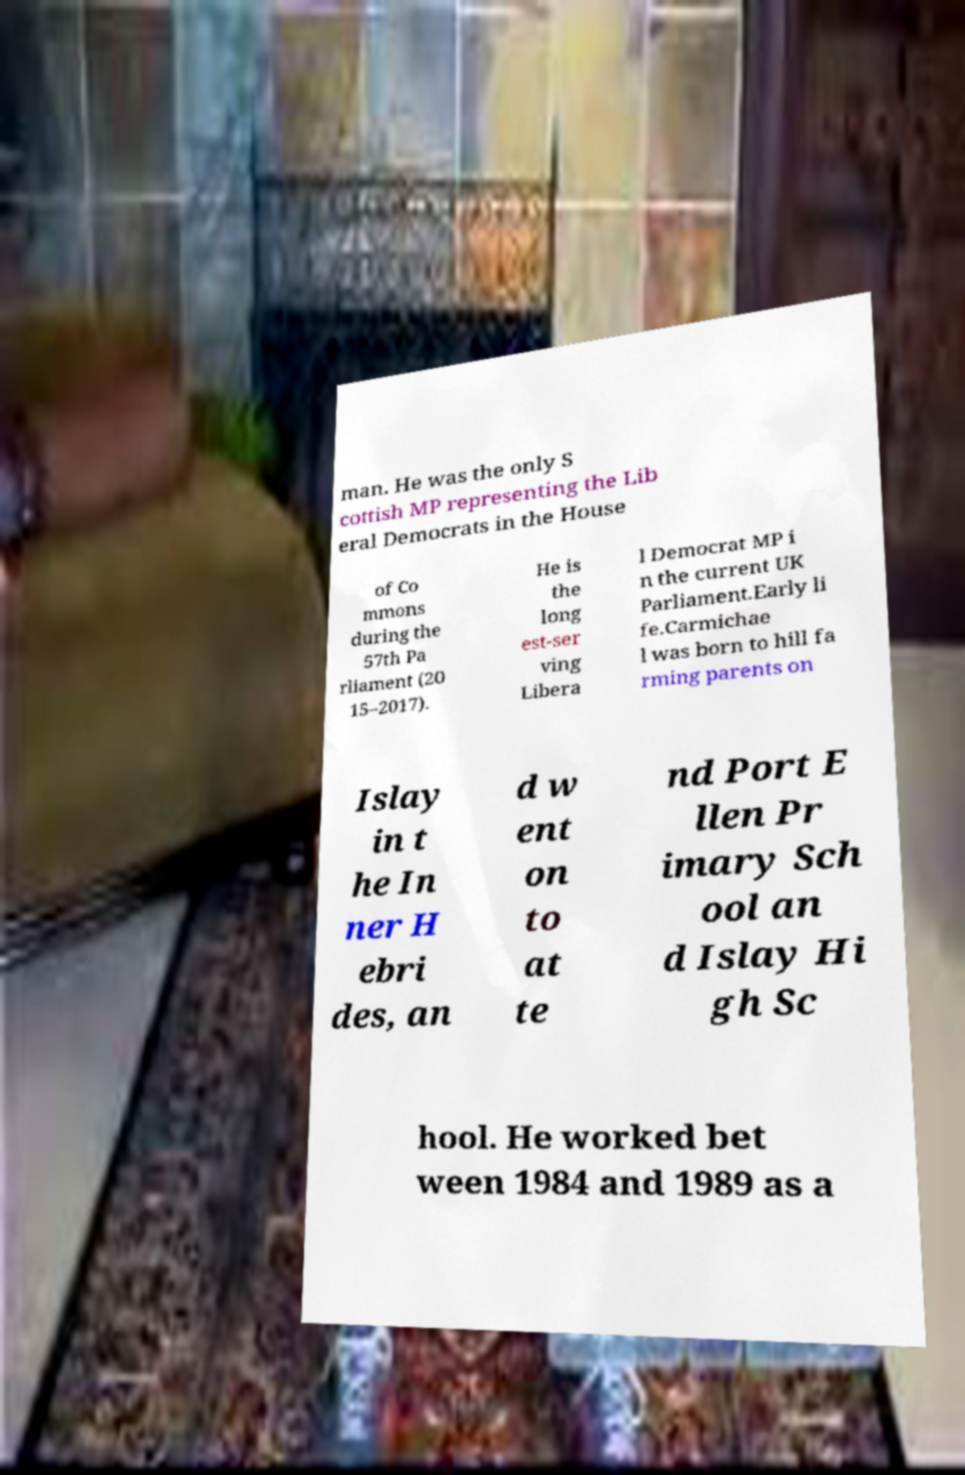Could you extract and type out the text from this image? man. He was the only S cottish MP representing the Lib eral Democrats in the House of Co mmons during the 57th Pa rliament (20 15–2017). He is the long est-ser ving Libera l Democrat MP i n the current UK Parliament.Early li fe.Carmichae l was born to hill fa rming parents on Islay in t he In ner H ebri des, an d w ent on to at te nd Port E llen Pr imary Sch ool an d Islay Hi gh Sc hool. He worked bet ween 1984 and 1989 as a 